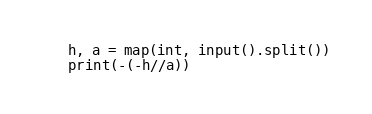Convert code to text. <code><loc_0><loc_0><loc_500><loc_500><_Python_>h, a = map(int, input().split())
print(-(-h//a))</code> 